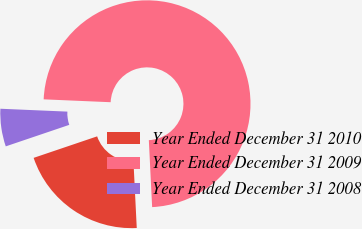Convert chart. <chart><loc_0><loc_0><loc_500><loc_500><pie_chart><fcel>Year Ended December 31 2010<fcel>Year Ended December 31 2009<fcel>Year Ended December 31 2008<nl><fcel>20.59%<fcel>73.53%<fcel>5.88%<nl></chart> 